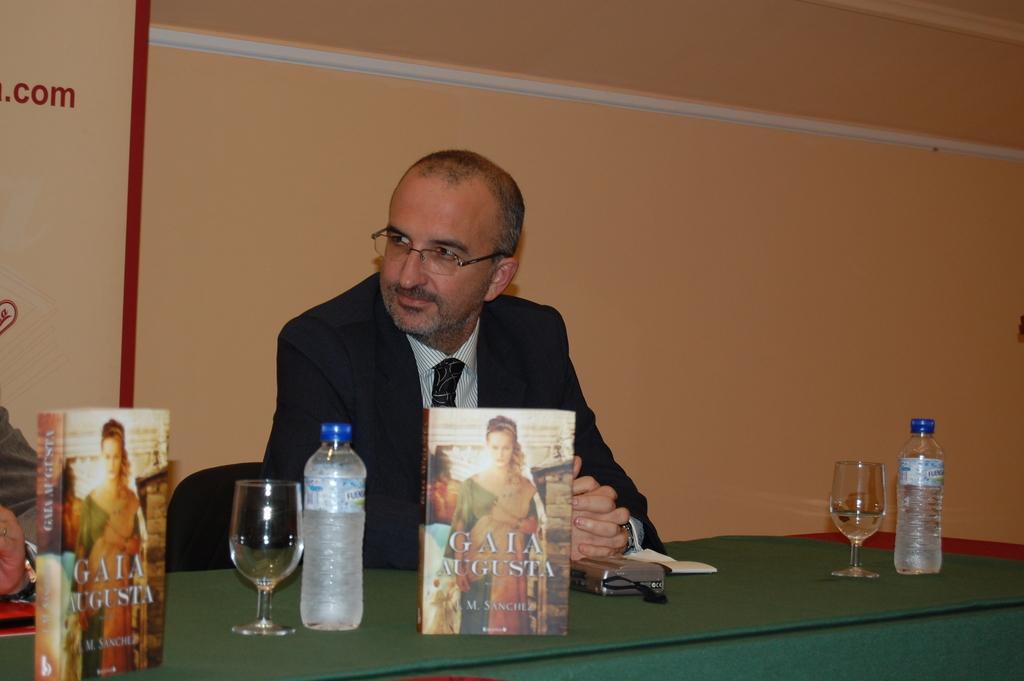Who is present in the image? There is a man in the image. What is the man wearing? The man is wearing a suit, shirt, and tie. What is the man doing in the image? The man is sitting on a chair. What objects can be seen on the table in the image? There is a glass, a bottle, and a paper on the table. What color are the man's eyes in the image? The provided facts do not mention the color of the man's eyes, so we cannot determine that information from the image. 